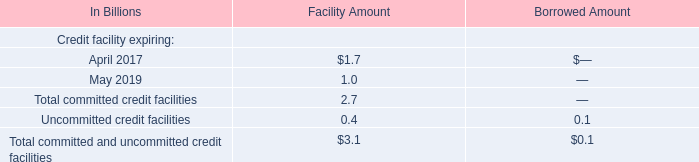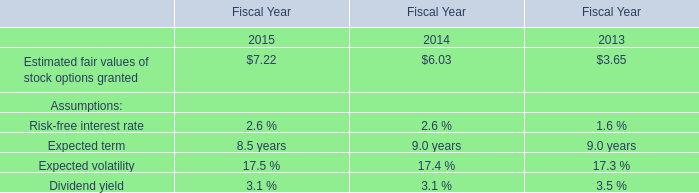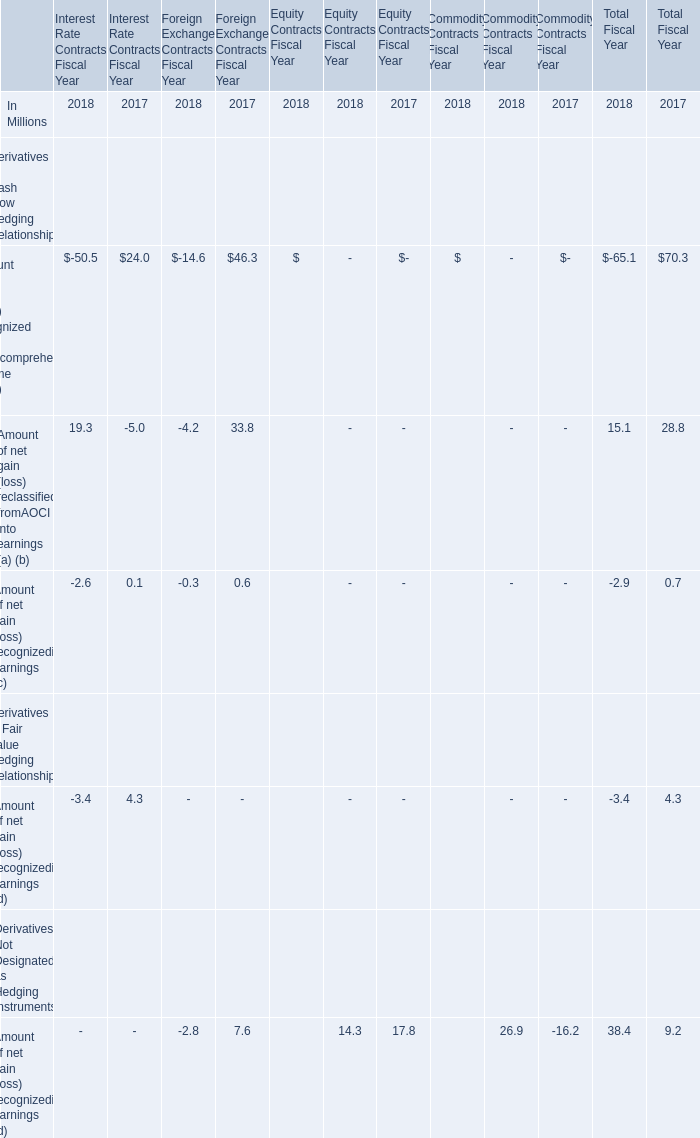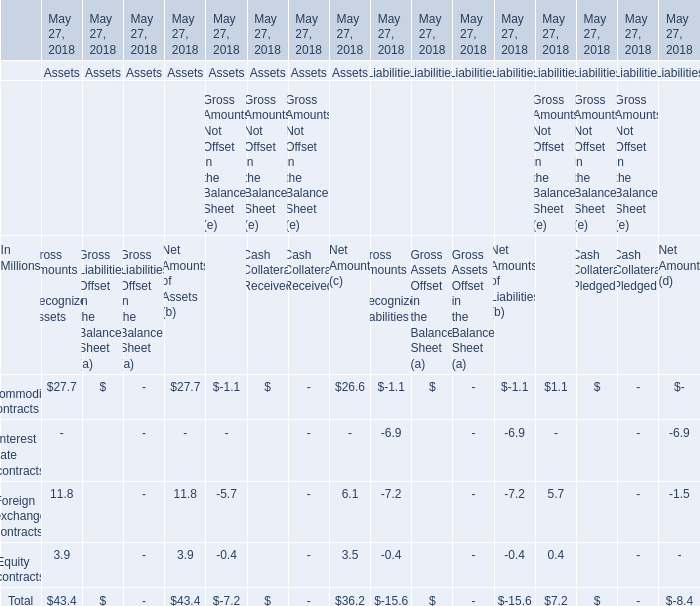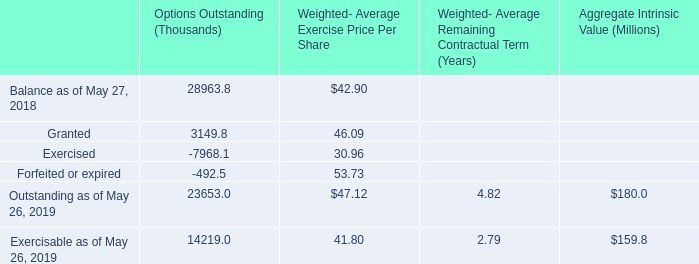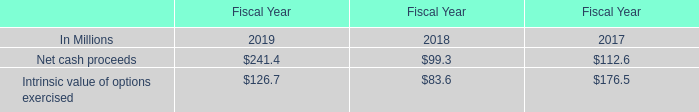Does the value of Amount of gain (loss) recognized in othercomprehensive income (OCI) (a) in 2018 greater than that in 2017? 
Answer: no. 